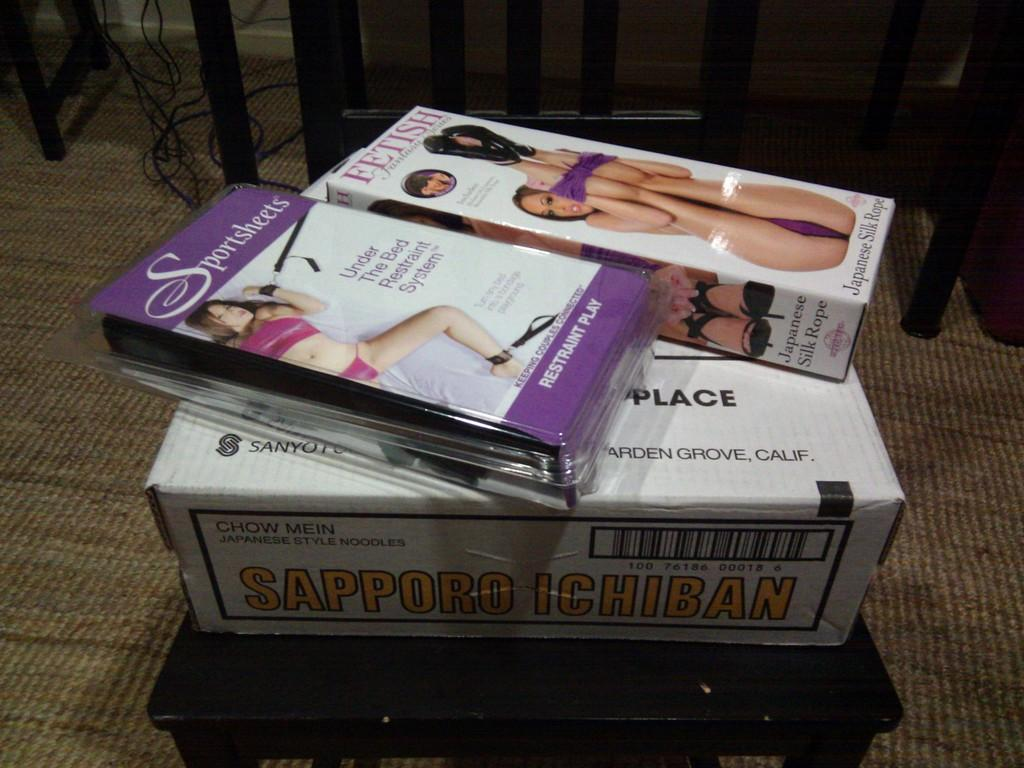Provide a one-sentence caption for the provided image. Two adult video tapes placed on top of a "Sapporo Ichiban" box. 